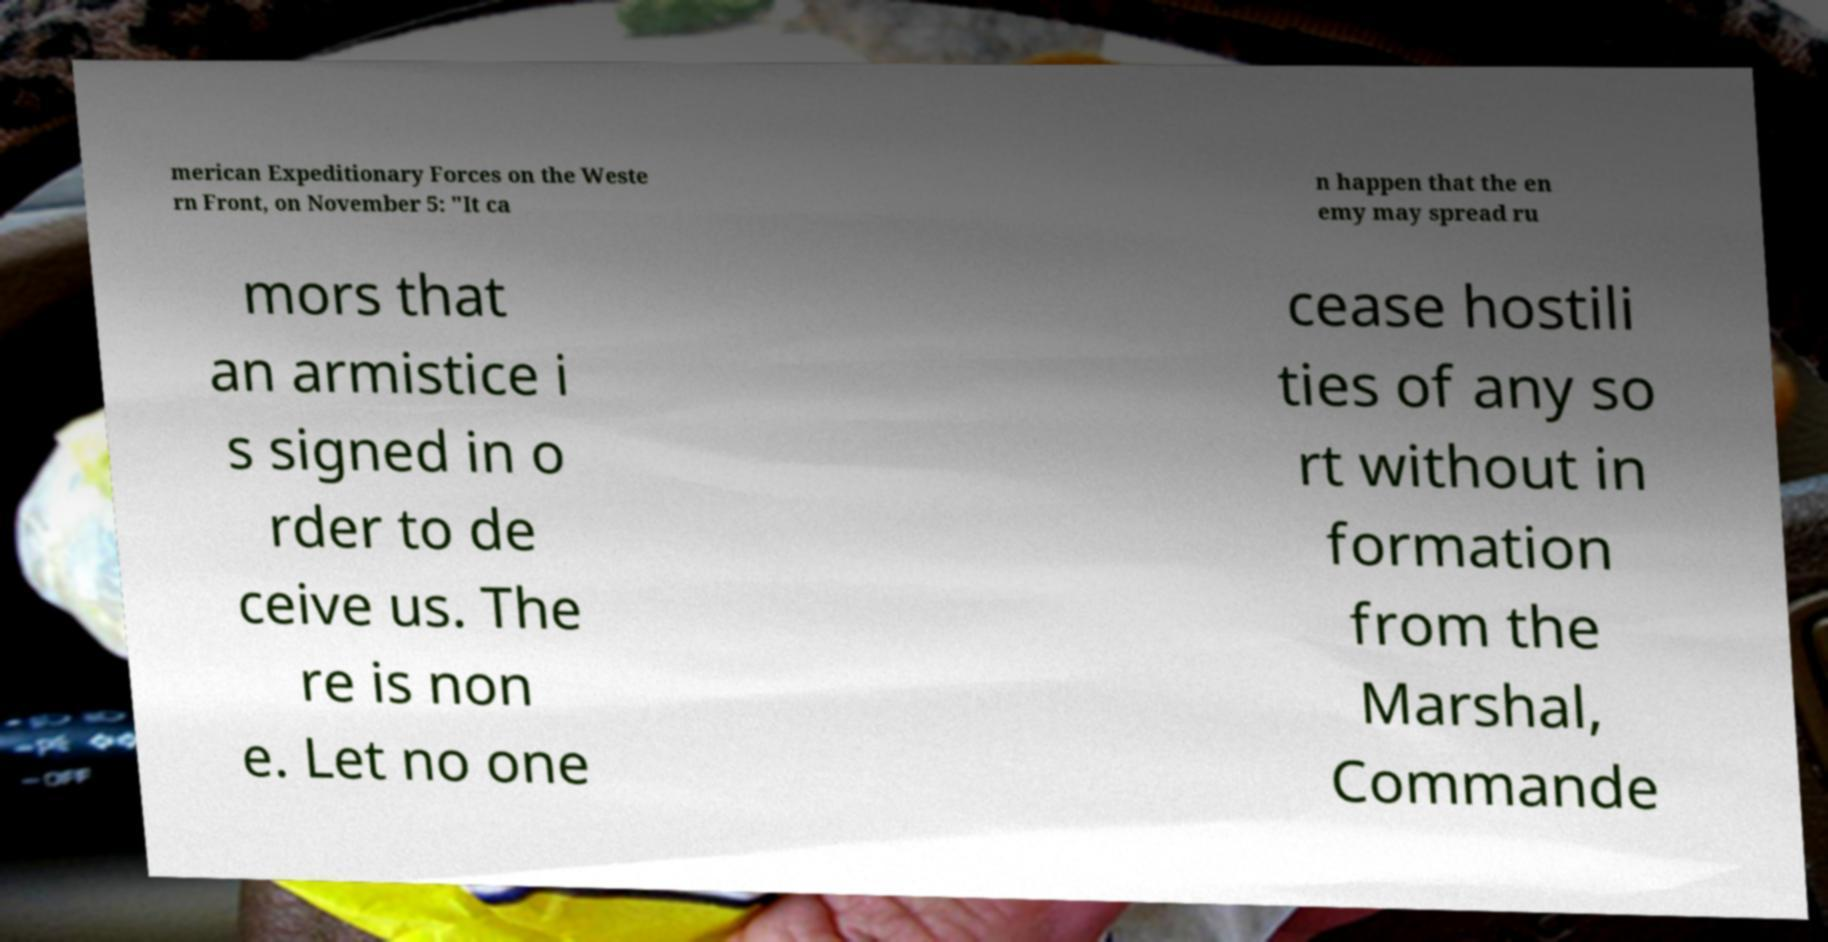There's text embedded in this image that I need extracted. Can you transcribe it verbatim? merican Expeditionary Forces on the Weste rn Front, on November 5: "It ca n happen that the en emy may spread ru mors that an armistice i s signed in o rder to de ceive us. The re is non e. Let no one cease hostili ties of any so rt without in formation from the Marshal, Commande 